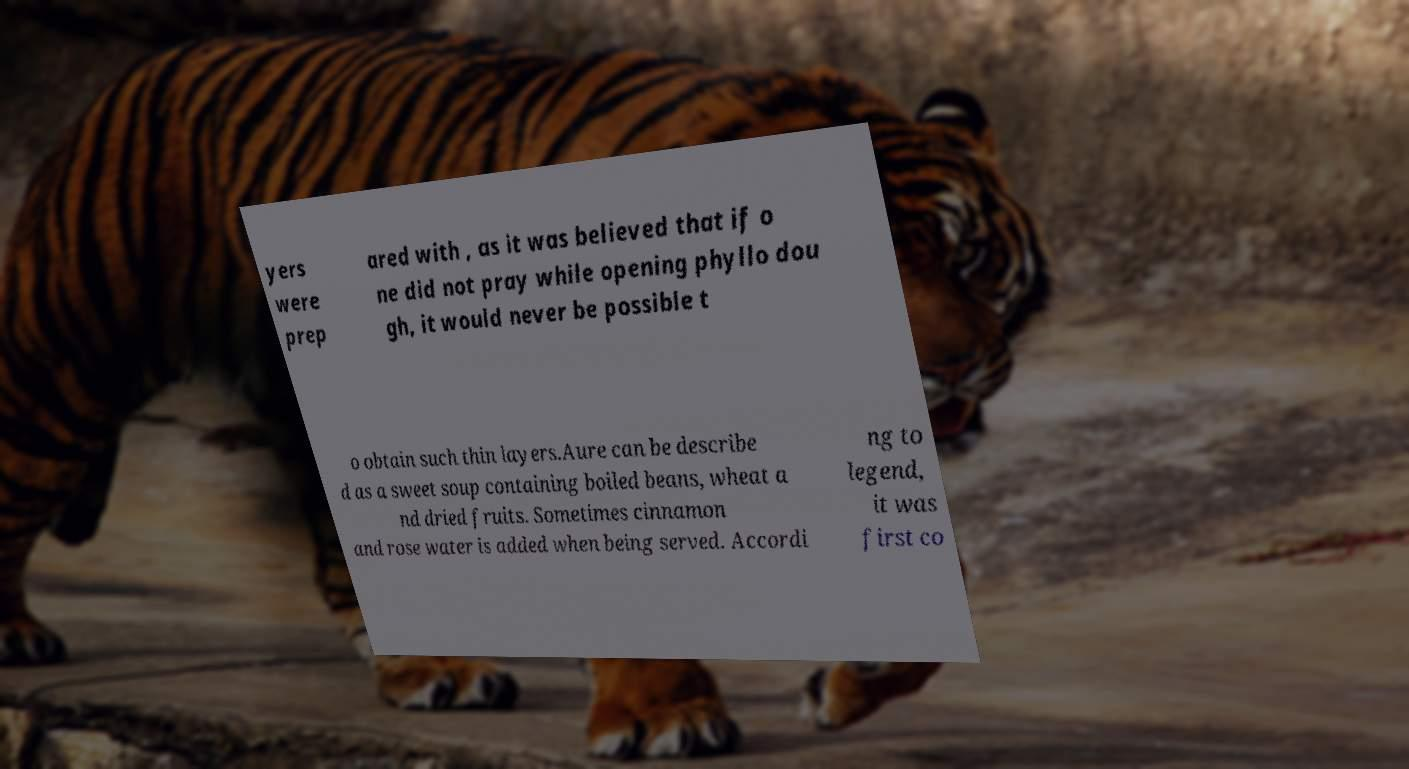Could you assist in decoding the text presented in this image and type it out clearly? yers were prep ared with , as it was believed that if o ne did not pray while opening phyllo dou gh, it would never be possible t o obtain such thin layers.Aure can be describe d as a sweet soup containing boiled beans, wheat a nd dried fruits. Sometimes cinnamon and rose water is added when being served. Accordi ng to legend, it was first co 